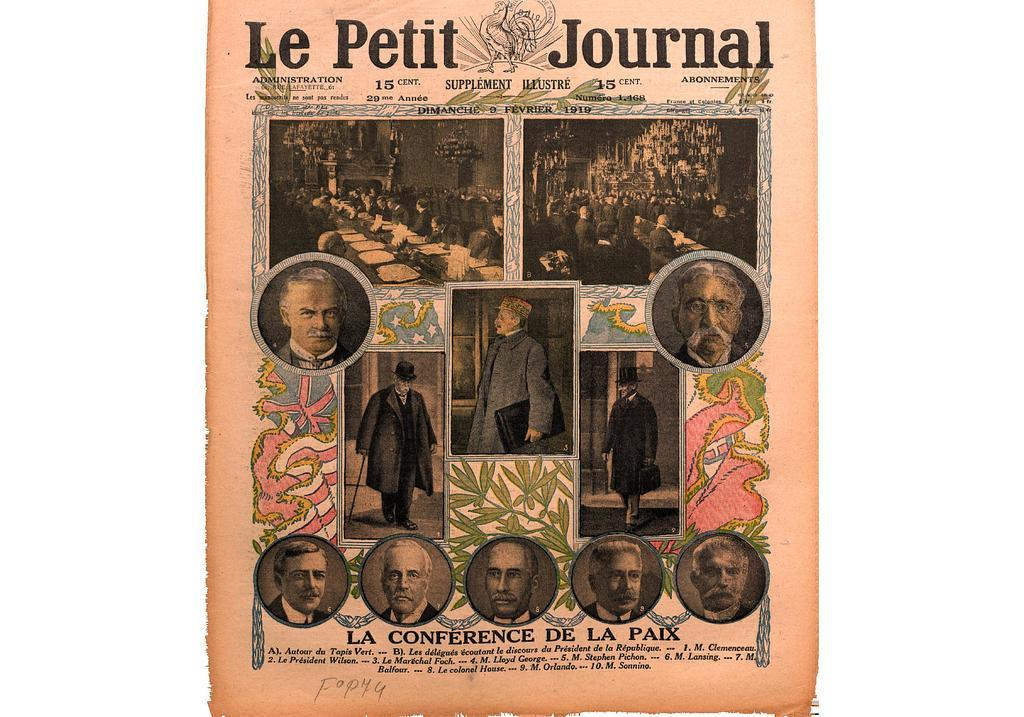What is present in the image that contains visual information? There is a paper in the image that contains pictures of people wearing clothes. What else can be found on the paper besides the pictures? The paper contains text. What type of mask is being worn by the people on the paper? There is no mask visible on the people in the pictures on the paper. What kind of machine is depicted on the paper? There is no machine depicted on the paper; it contains pictures of people wearing clothes and text. 